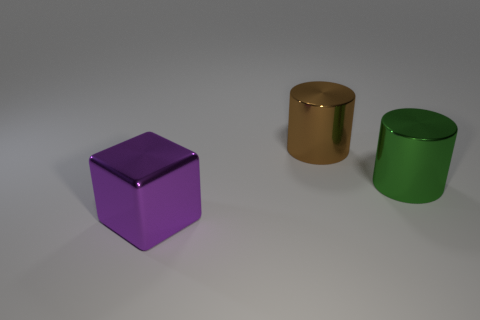Add 2 green metallic cubes. How many objects exist? 5 Subtract all blocks. How many objects are left? 2 Subtract 0 cyan cylinders. How many objects are left? 3 Subtract all metal blocks. Subtract all green metallic objects. How many objects are left? 1 Add 3 brown objects. How many brown objects are left? 4 Add 1 brown metal cylinders. How many brown metal cylinders exist? 2 